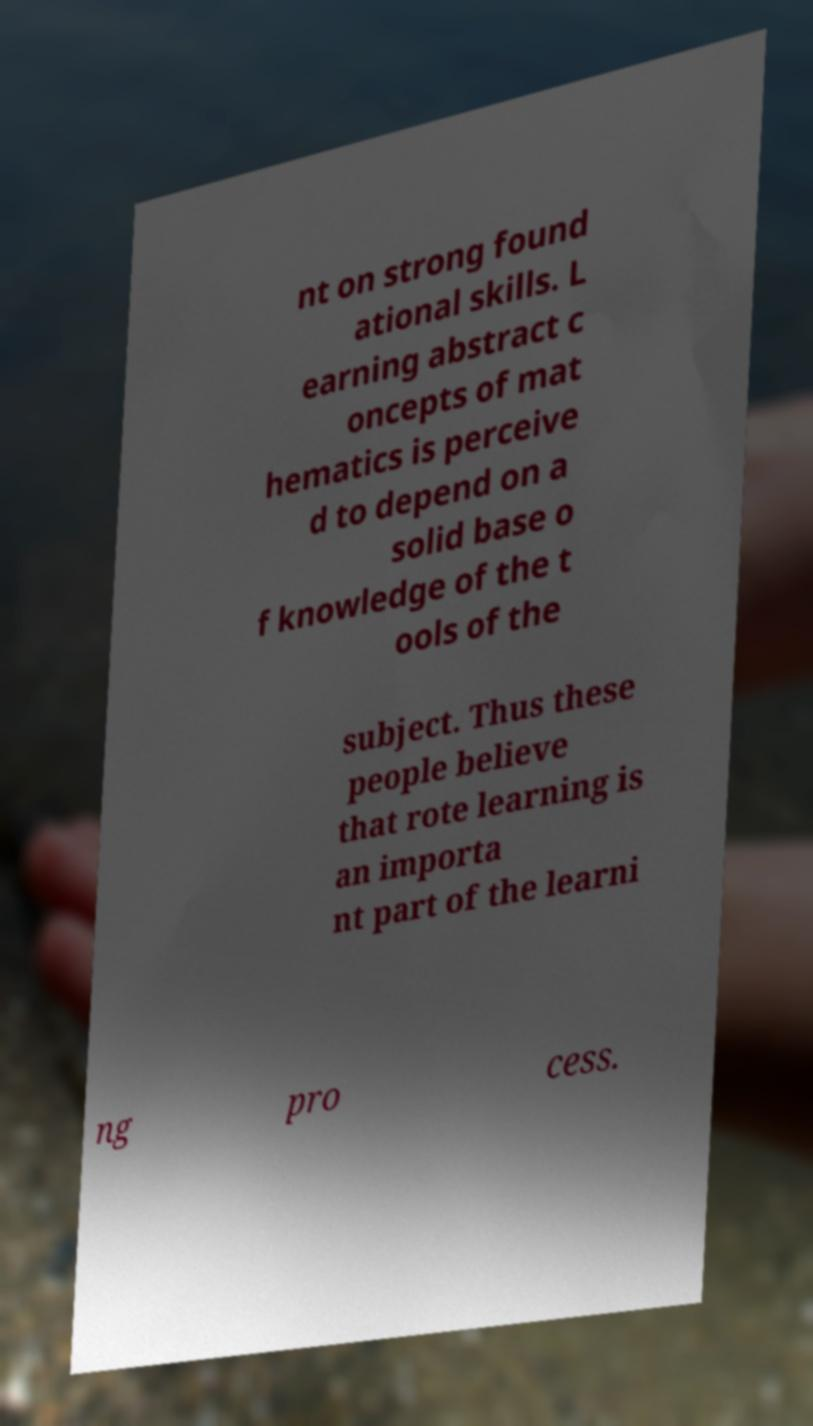What messages or text are displayed in this image? I need them in a readable, typed format. nt on strong found ational skills. L earning abstract c oncepts of mat hematics is perceive d to depend on a solid base o f knowledge of the t ools of the subject. Thus these people believe that rote learning is an importa nt part of the learni ng pro cess. 